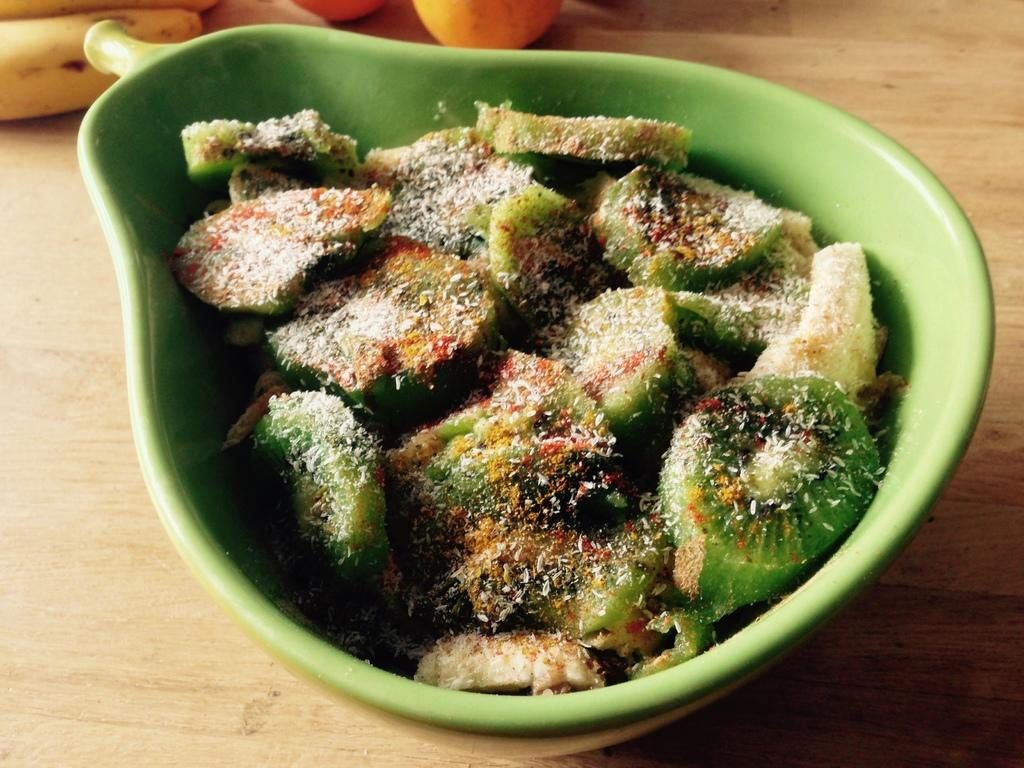What is in the bowl that is visible in the image? The bowl contains slices of fruits in the image. What types of fruits can be seen in the bowl? The bowl contains slices of fruits, but the specific types are not mentioned in the facts. Besides the bowl, what other items can be seen on the table? There are bananas and oranges on the table in the image. What type of doctor is examining the fruits in the image? There is no doctor present in the image; it only features a bowl of sliced fruits, bananas, and oranges on a table. 